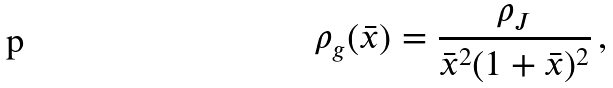Convert formula to latex. <formula><loc_0><loc_0><loc_500><loc_500>\rho _ { g } ( \bar { x } ) = \frac { \rho _ { J } } { \bar { x } ^ { 2 } ( 1 + \bar { x } ) ^ { 2 } } \, ,</formula> 